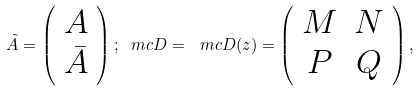Convert formula to latex. <formula><loc_0><loc_0><loc_500><loc_500>\tilde { A } = \left ( \begin{array} { c } A \\ \bar { A } \end{array} \right ) ; \ m c { D } = { \ m c { D } } ( z ) = \left ( \begin{array} { c c } M & N \\ P & Q \end{array} \right ) ,</formula> 